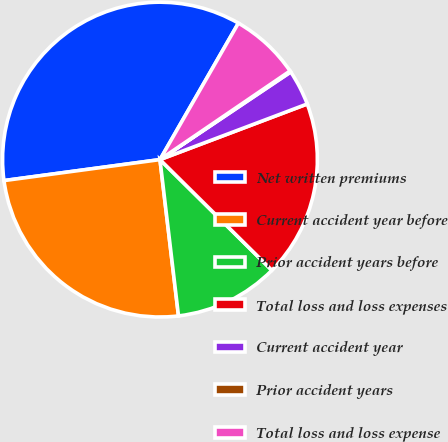Convert chart. <chart><loc_0><loc_0><loc_500><loc_500><pie_chart><fcel>Net written premiums<fcel>Current accident year before<fcel>Prior accident years before<fcel>Total loss and loss expenses<fcel>Current accident year<fcel>Prior accident years<fcel>Total loss and loss expense<nl><fcel>35.43%<fcel>24.75%<fcel>10.71%<fcel>18.16%<fcel>3.65%<fcel>0.12%<fcel>7.18%<nl></chart> 